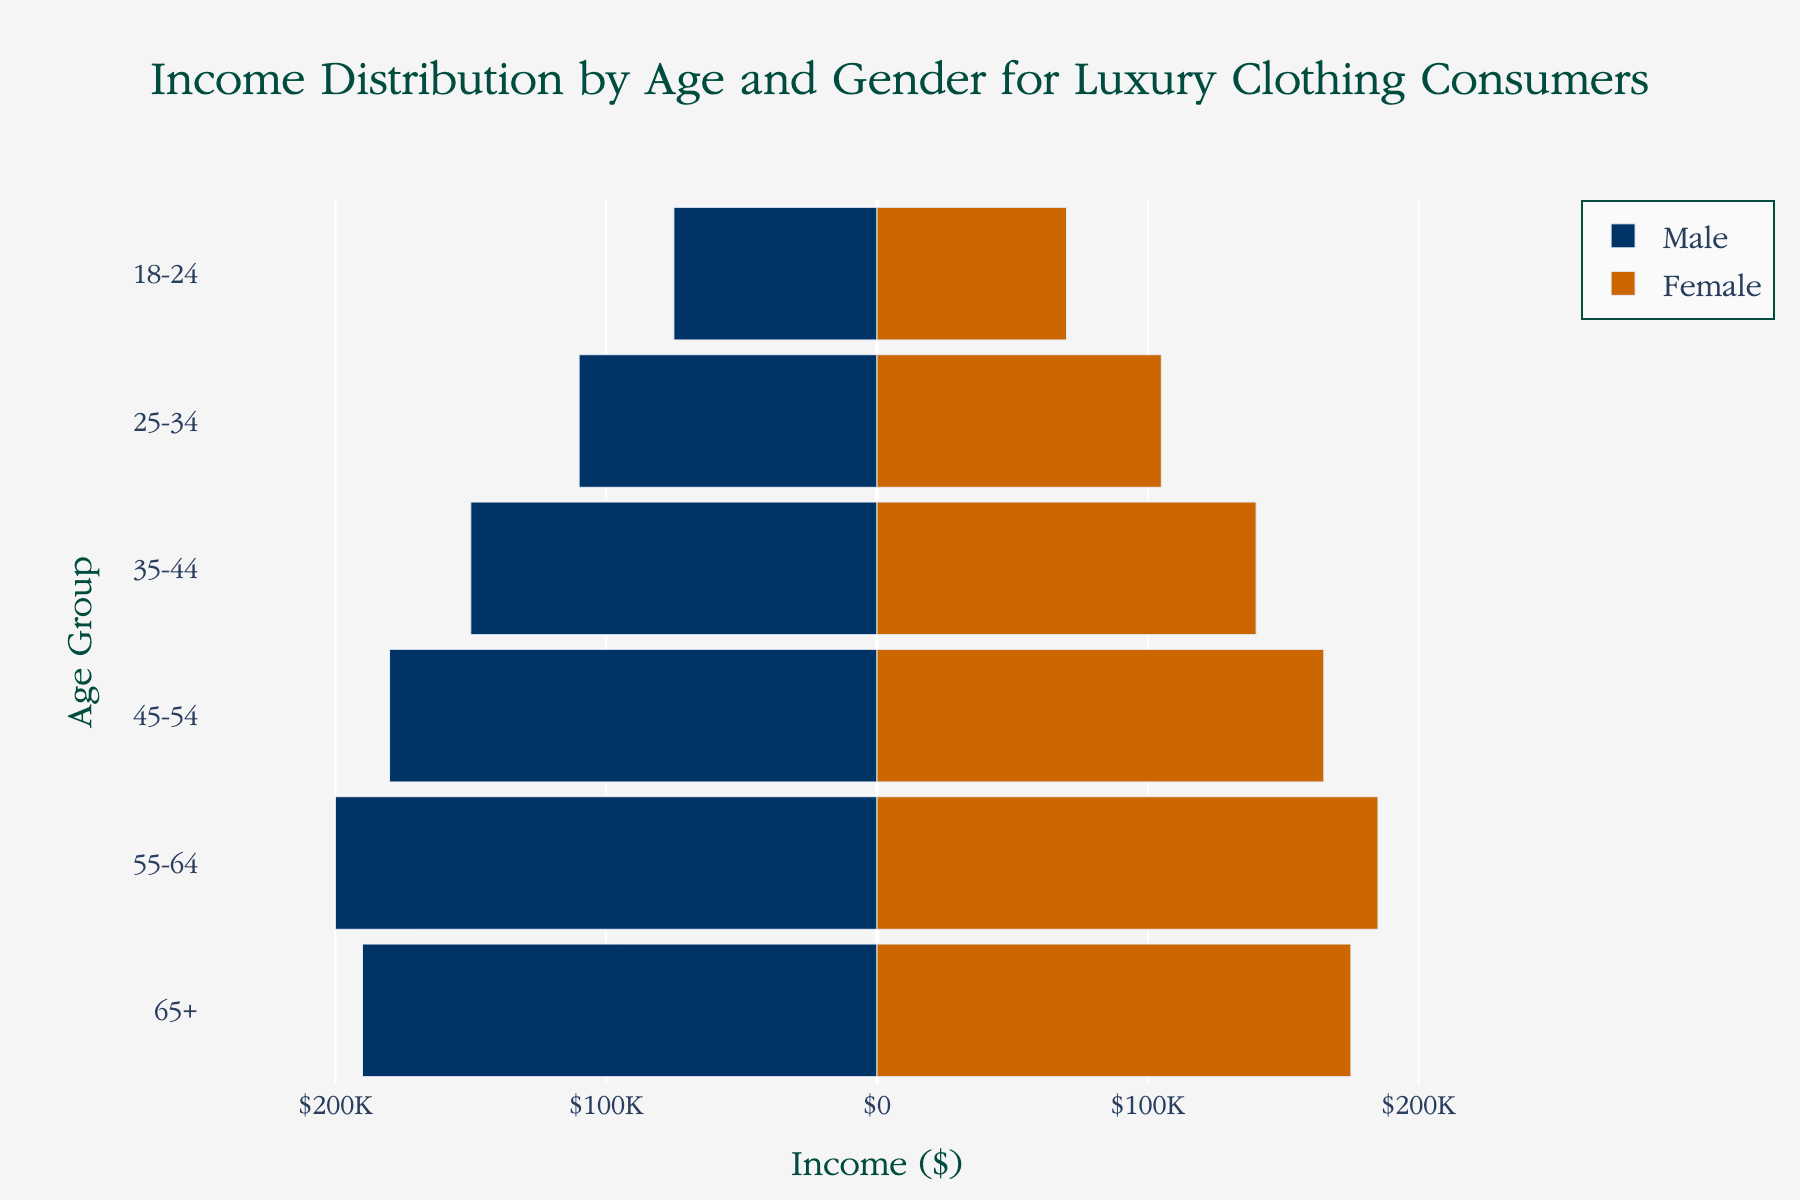What is the income for males in the 25-34 age group? Look at the male bar for the 25-34 age group. The income is $110,000.
Answer: $110,000 How does the income of females in the 35-44 age group compare to the income of males in the 55-64 age group? Compare the female bar for 35-44 ($140,000) to the male bar for 55-64 ($200,000). The males in 55-64 earn more.
Answer: Males in 55-64 earn more What is the average income of males across all age groups? Find the male incomes (75,000 + 110,000 + 150,000 + 180,000 + 200,000 + 190,000) and divide by the number of age groups (6). The average is (75,000 + 110,000 + 150,000 + 180,000 + 200,000 + 190,000) / 6 = $150,833.33.
Answer: $150,833.33 What is the difference in income between males and females in the 45-54 age group? Find the difference between male income (180,000) and female income (165,000) for the 45-54 age group. The difference is 180,000 - 165,000 = $15,000.
Answer: $15,000 Which age group has the smallest gender income gap? Calculate the absolute differences for all groups: 18-24 (5,000), 25-34 (5,000), 35-44 (10,000), 45-54 (15,000), 55-64 (15,000), 65+ (15,000). The smallest gap is in 18-24 and 25-34 with $5,000.
Answer: 18-24 and 25-34 Does any age group have equal male and female incomes? Check if there are any age groups where male and female income bars are of equal length. None of them are equal.
Answer: No What can you infer about the trend in income as age increases for both males and females? Observe the income bars as age increases. Both male and female incomes generally increase with age, peaking in 55-64 and slightly decreasing for 65+.
Answer: Incomes generally increase with age, peak in 55-64 In which age group do males have the highest income? Find the longest male income bar. It's the one for the 55-64 age group at $200,000.
Answer: 55-64 How does the average income for females compare to males across all age groups? Calculate average for males ($150,833.33) and females (70,000 + 105,000 + 140,000 + 165,000 + 185,000 + 175,000) / 6 = $140,000. Females earn less on average.
Answer: Males earn more 